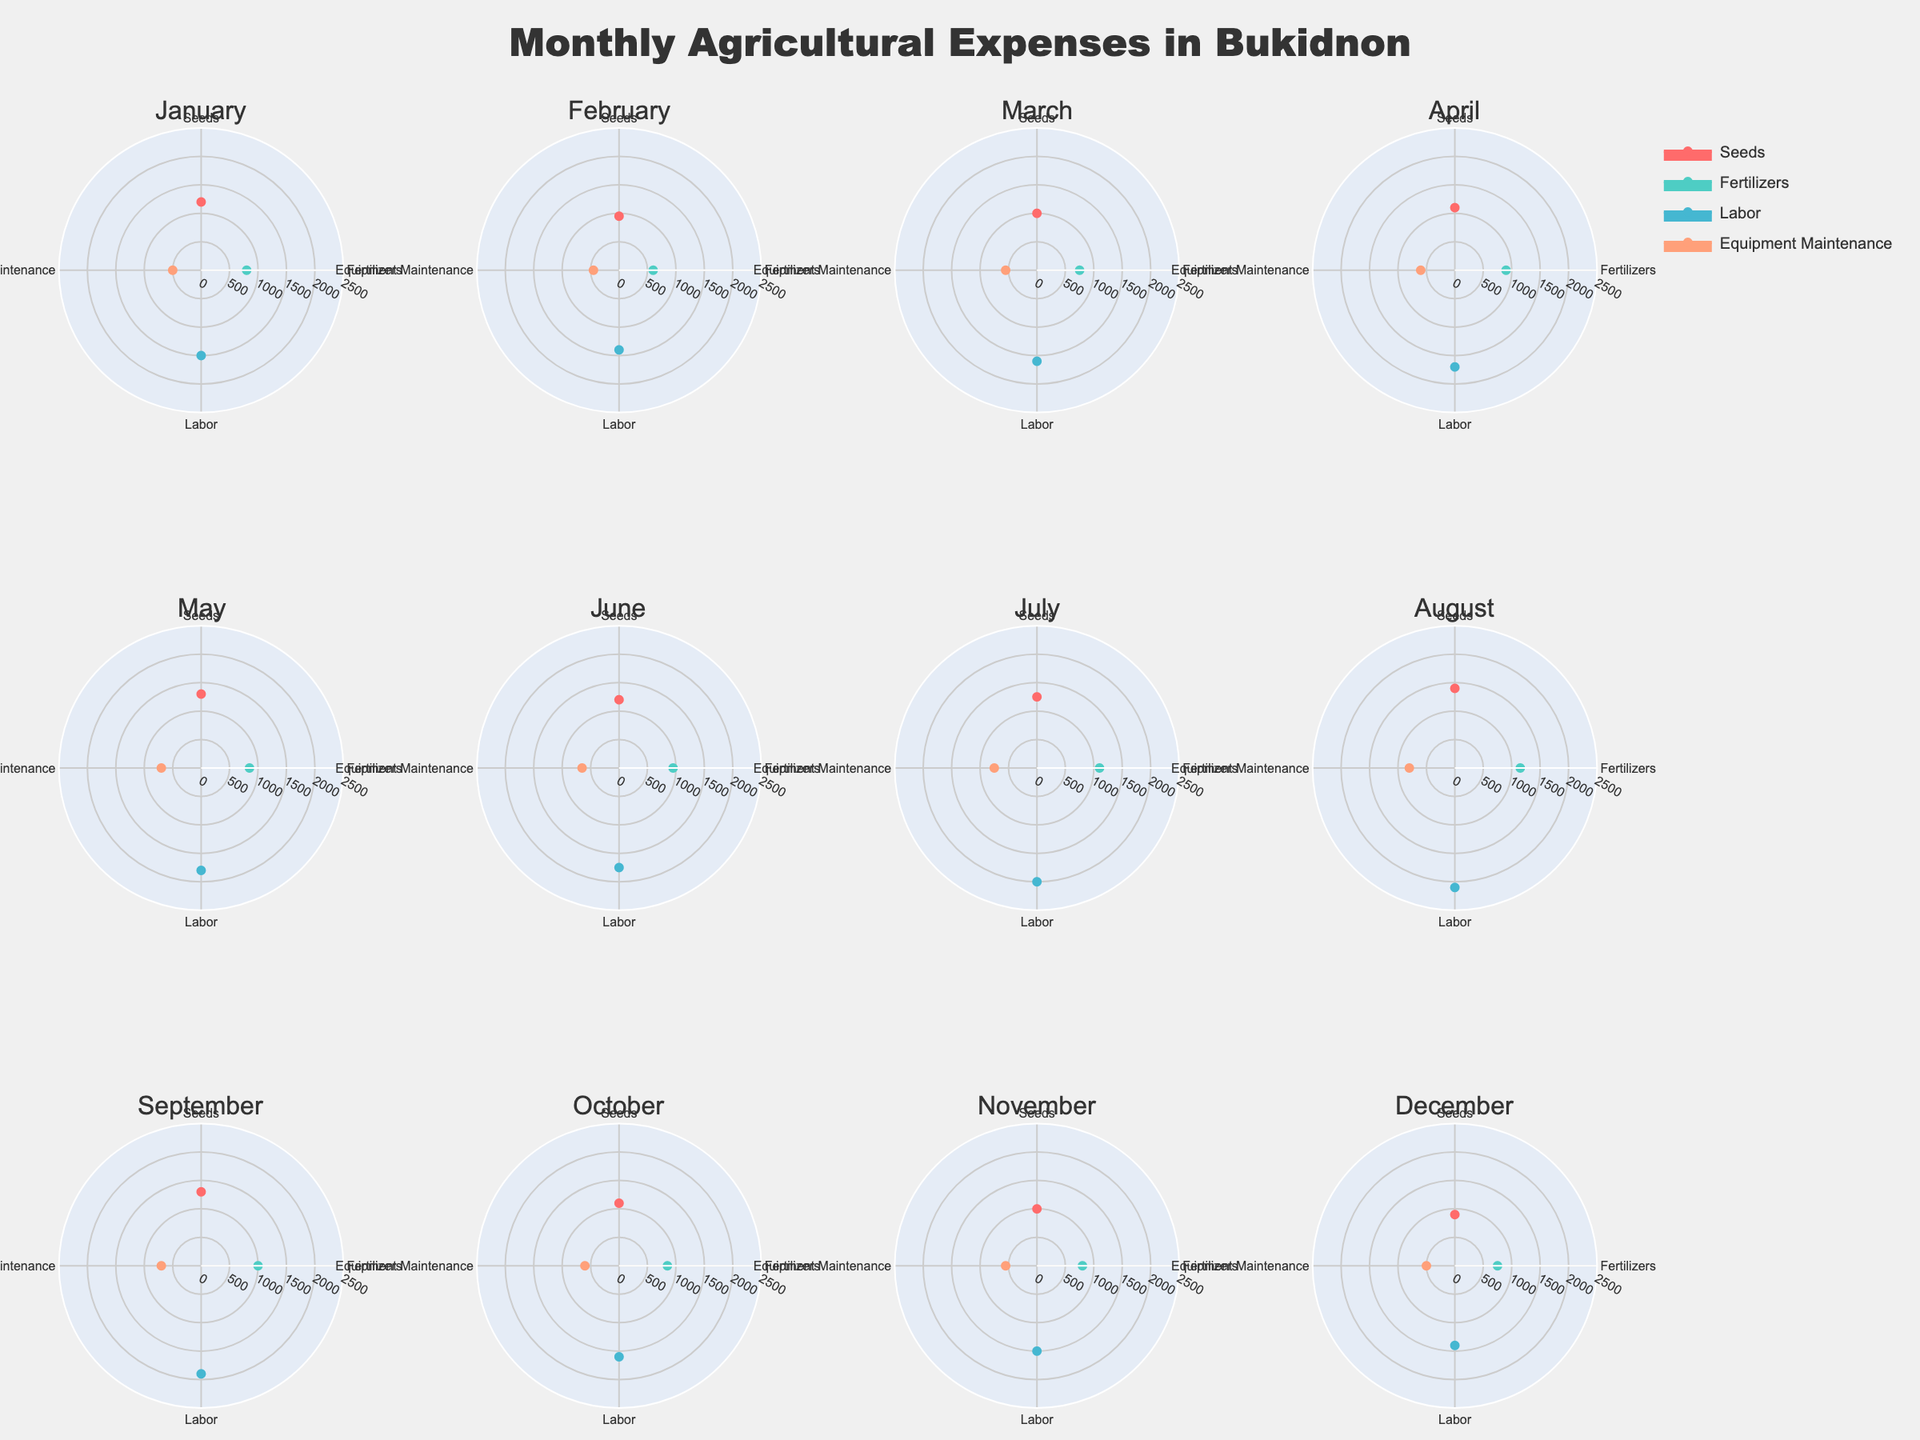What are the main categories shown in the polar charts? The polar charts depict the distribution of agricultural expenses across various categories like seeds, fertilizers, labor, and equipment maintenance. Each of these categories is represented by a different color and labeled accordingly in the figure.
Answer: Seeds, Fertilizers, Labor, Equipment Maintenance Which month had the highest expense for labor? By observing the polar charts, we can compare the radial length of the labor category for each month. The labor expenses in the polar chart for August have the longest radial length, indicating the highest expenses.
Answer: August How much higher were labor expenses in August compared to July? August had labor expenses of 2100, and July had labor expenses of 2000. Subtracting the July expenses from August expenses gives 2100 - 2000 = 100.
Answer: 100 Which months had the lowest expense for seeds? By looking at the radial lengths for the seeds category across all subplots, December appears to have the shortest, indicating the lowest expense for seeds at 900. This is confirmed by the respective radial length.
Answer: December What is the average monthly expense for fertilizers? To calculate the average, sum the monthly expenses for fertilizers and divide by the number of months. Sum (800 + 600 + 750 + 900 + 850 + 950 + 1100 + 1150 + 1000 + 850 + 800 + 750) = 11500, Average = 11500 / 12 = 958.33
Answer: 958.33 What is the combined expense for equipment maintenance in April and May? Adding together the equipment maintenance expenses for April (600) and May (700) gives 600 + 700 = 1300.
Answer: 1300 In which month did the total agricultural expenses surpass 5000? By summing category expenses for each month and checking against the threshold: January (1200+800+1500+500 = 4000) is less than 5000, February (950+600+1400+450 = 3400) is less than 5000, and so on. The month of July (1250+1100+2000+750 = 5100) surpasses 5000.
Answer: July Which category had the most stable expenses throughout the year? Observing the consistency of radial lengths across all the months, Equipment Maintenance displays the least variation in radial lengths. This suggests that its expenses remain relatively stable throughout the year.
Answer: Equipment Maintenance What is the difference in seed expenses between March and June? The seed expenses in March are 1000, and in June they are 1200. Subtracting March from June gives 1200 - 1000 = 200.
Answer: 200 